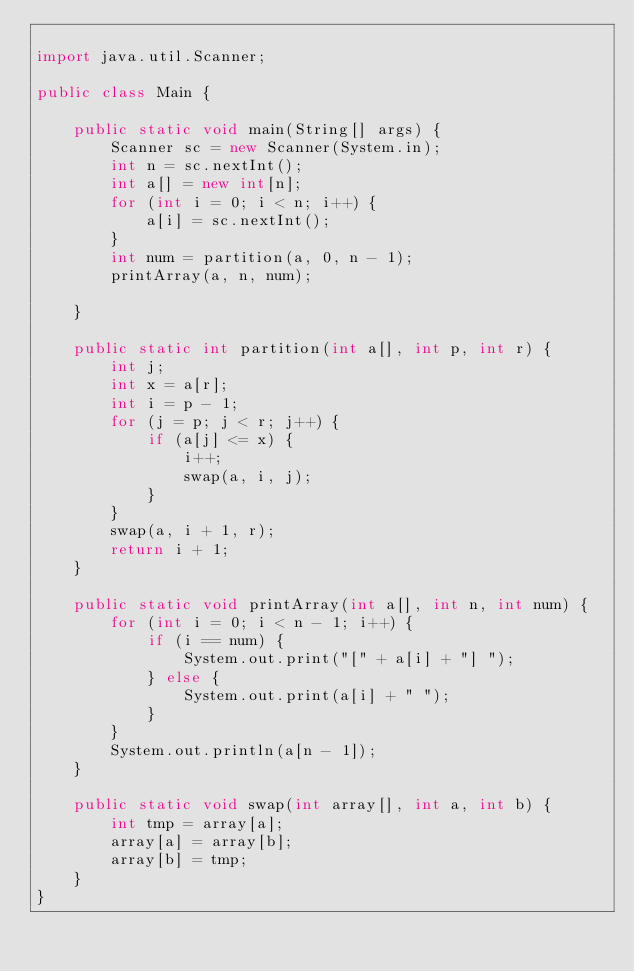Convert code to text. <code><loc_0><loc_0><loc_500><loc_500><_Java_>
import java.util.Scanner;

public class Main {

	public static void main(String[] args) {
		Scanner sc = new Scanner(System.in);
		int n = sc.nextInt();
		int a[] = new int[n];
		for (int i = 0; i < n; i++) {
			a[i] = sc.nextInt();
		}
		int num = partition(a, 0, n - 1);
		printArray(a, n, num);

	}

	public static int partition(int a[], int p, int r) {
		int j;
		int x = a[r];
		int i = p - 1;
		for (j = p; j < r; j++) {
			if (a[j] <= x) {
				i++;
				swap(a, i, j);
			}
		}
		swap(a, i + 1, r);
		return i + 1;
	}

	public static void printArray(int a[], int n, int num) {
		for (int i = 0; i < n - 1; i++) {
			if (i == num) {
				System.out.print("[" + a[i] + "] ");
			} else {
				System.out.print(a[i] + " ");
			}
		}
		System.out.println(a[n - 1]);
	}

	public static void swap(int array[], int a, int b) {
		int tmp = array[a];
		array[a] = array[b];
		array[b] = tmp;
	}
}

</code> 